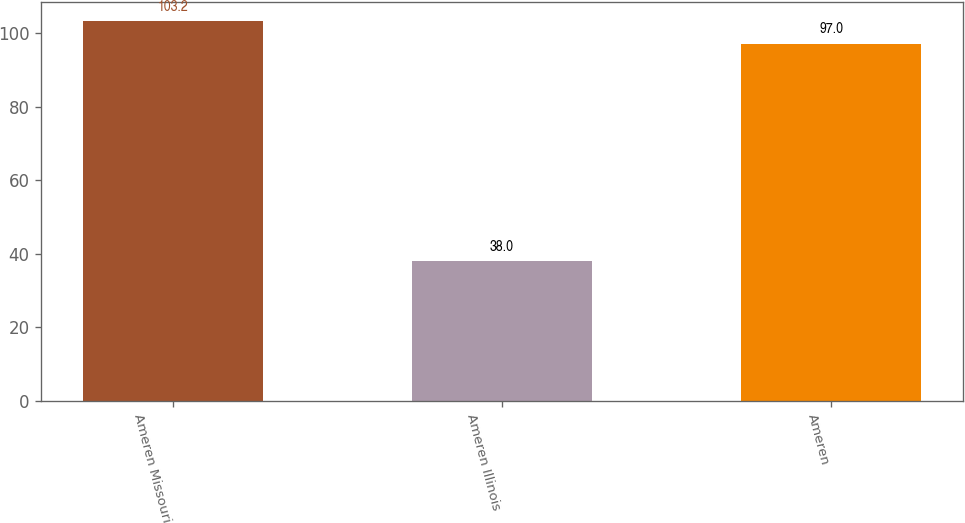Convert chart to OTSL. <chart><loc_0><loc_0><loc_500><loc_500><bar_chart><fcel>Ameren Missouri<fcel>Ameren Illinois<fcel>Ameren<nl><fcel>103.2<fcel>38<fcel>97<nl></chart> 